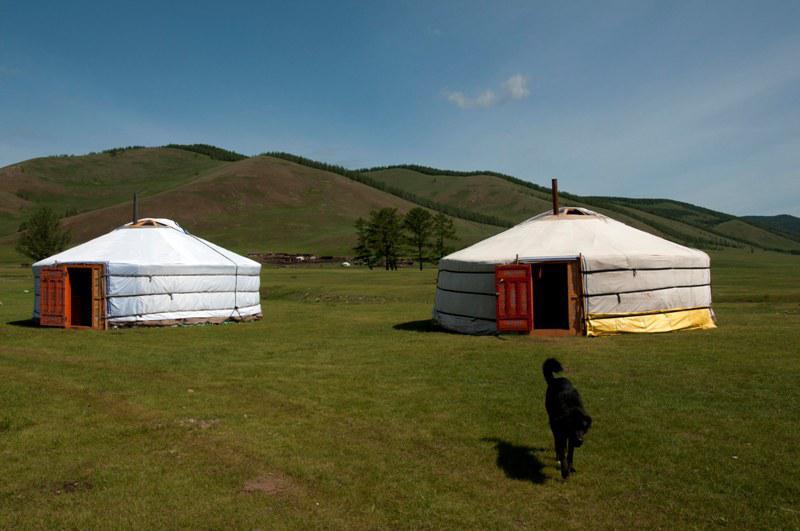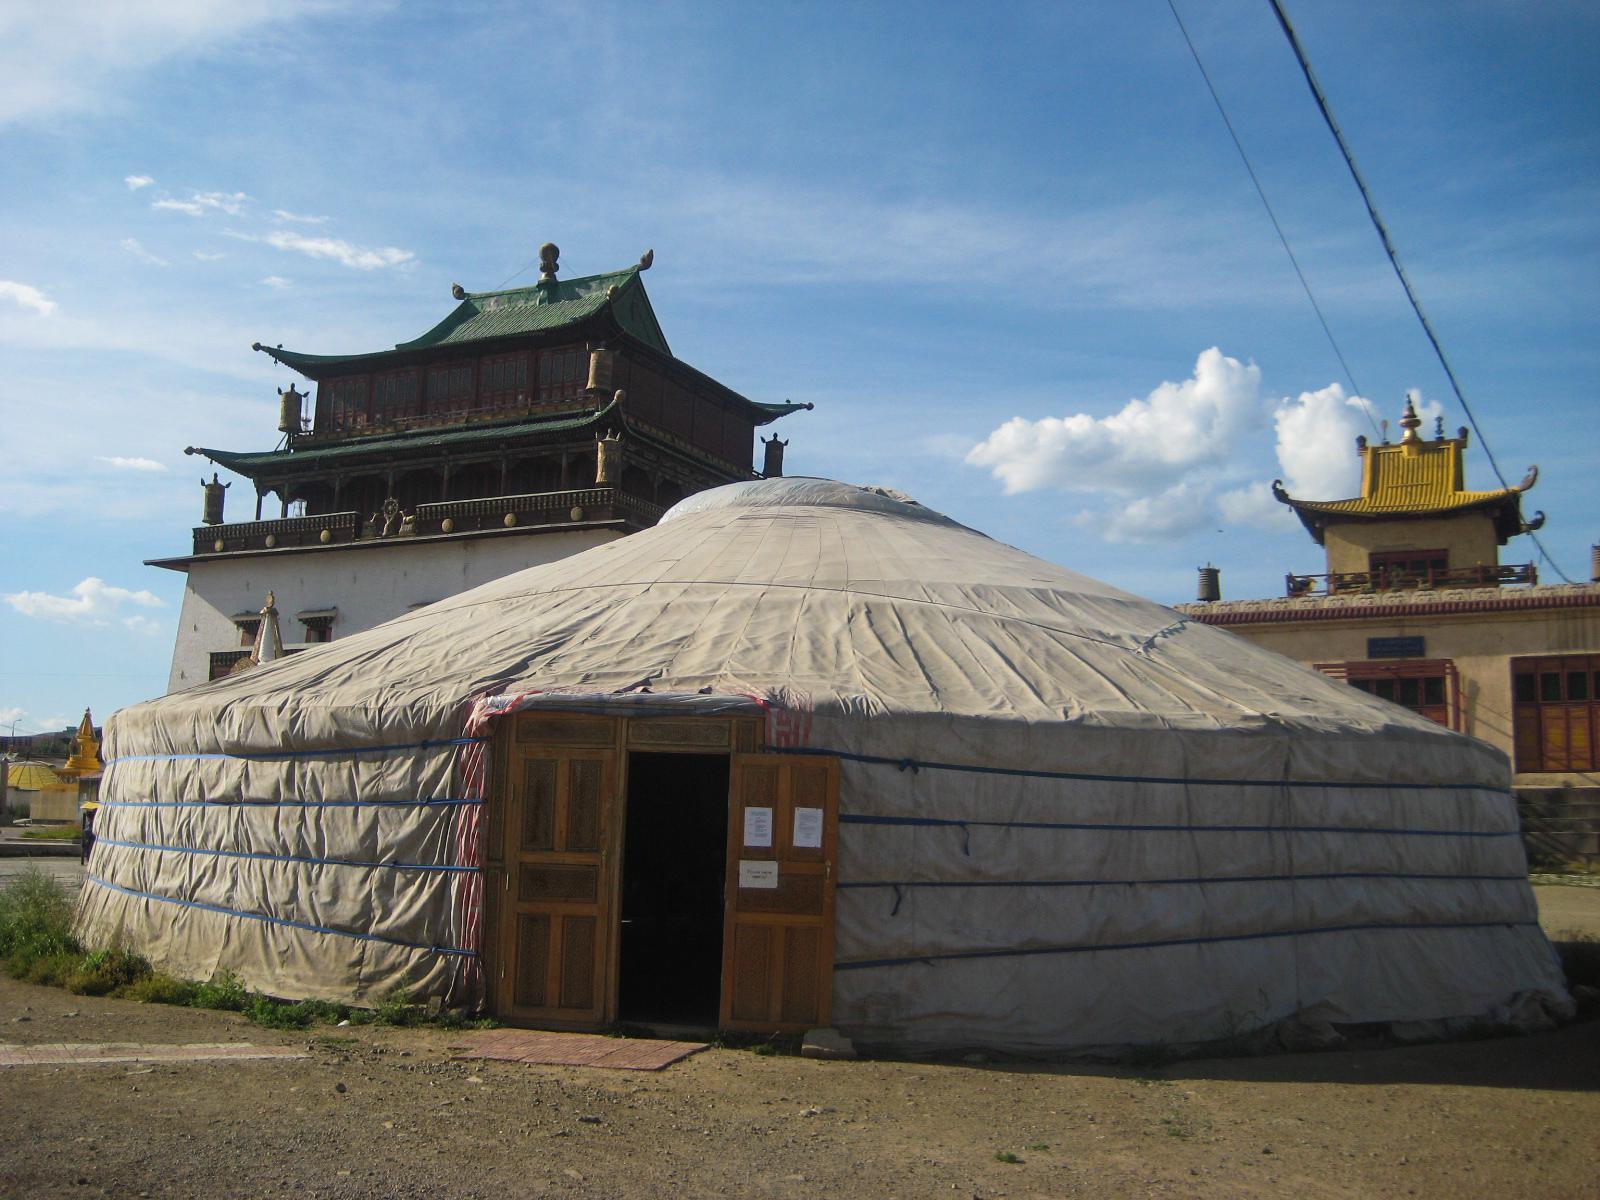The first image is the image on the left, the second image is the image on the right. Analyze the images presented: Is the assertion "Exactly three round house structures are shown." valid? Answer yes or no. Yes. The first image is the image on the left, the second image is the image on the right. For the images shown, is this caption "An image includes at least four cone-topped tents in a row." true? Answer yes or no. No. 